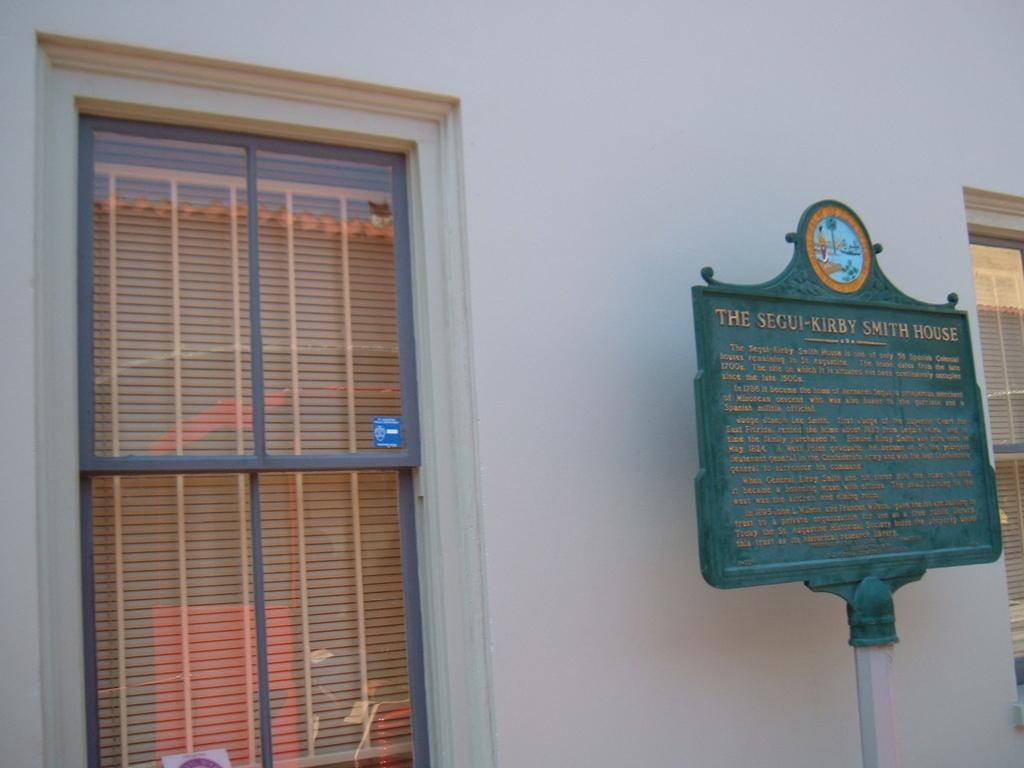<image>
Create a compact narrative representing the image presented. A green sign outside the house explains the details about the Segui-Kirby Smith house. 